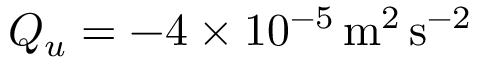Convert formula to latex. <formula><loc_0><loc_0><loc_500><loc_500>Q _ { u } = - 4 \times 1 0 ^ { - 5 } \, m ^ { 2 } \, s ^ { - 2 }</formula> 